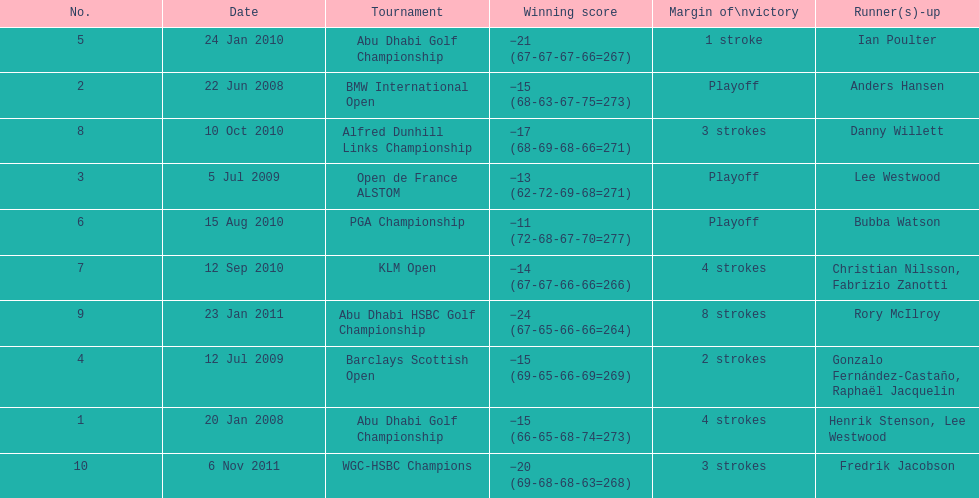Parse the table in full. {'header': ['No.', 'Date', 'Tournament', 'Winning score', 'Margin of\\nvictory', 'Runner(s)-up'], 'rows': [['5', '24 Jan 2010', 'Abu Dhabi Golf Championship', '−21 (67-67-67-66=267)', '1 stroke', 'Ian Poulter'], ['2', '22 Jun 2008', 'BMW International Open', '−15 (68-63-67-75=273)', 'Playoff', 'Anders Hansen'], ['8', '10 Oct 2010', 'Alfred Dunhill Links Championship', '−17 (68-69-68-66=271)', '3 strokes', 'Danny Willett'], ['3', '5 Jul 2009', 'Open de France ALSTOM', '−13 (62-72-69-68=271)', 'Playoff', 'Lee Westwood'], ['6', '15 Aug 2010', 'PGA Championship', '−11 (72-68-67-70=277)', 'Playoff', 'Bubba Watson'], ['7', '12 Sep 2010', 'KLM Open', '−14 (67-67-66-66=266)', '4 strokes', 'Christian Nilsson, Fabrizio Zanotti'], ['9', '23 Jan 2011', 'Abu Dhabi HSBC Golf Championship', '−24 (67-65-66-66=264)', '8 strokes', 'Rory McIlroy'], ['4', '12 Jul 2009', 'Barclays Scottish Open', '−15 (69-65-66-69=269)', '2 strokes', 'Gonzalo Fernández-Castaño, Raphaël Jacquelin'], ['1', '20 Jan 2008', 'Abu Dhabi Golf Championship', '−15 (66-65-68-74=273)', '4 strokes', 'Henrik Stenson, Lee Westwood'], ['10', '6 Nov 2011', 'WGC-HSBC Champions', '−20 (69-68-68-63=268)', '3 strokes', 'Fredrik Jacobson']]} How many total tournaments has he won? 10. 